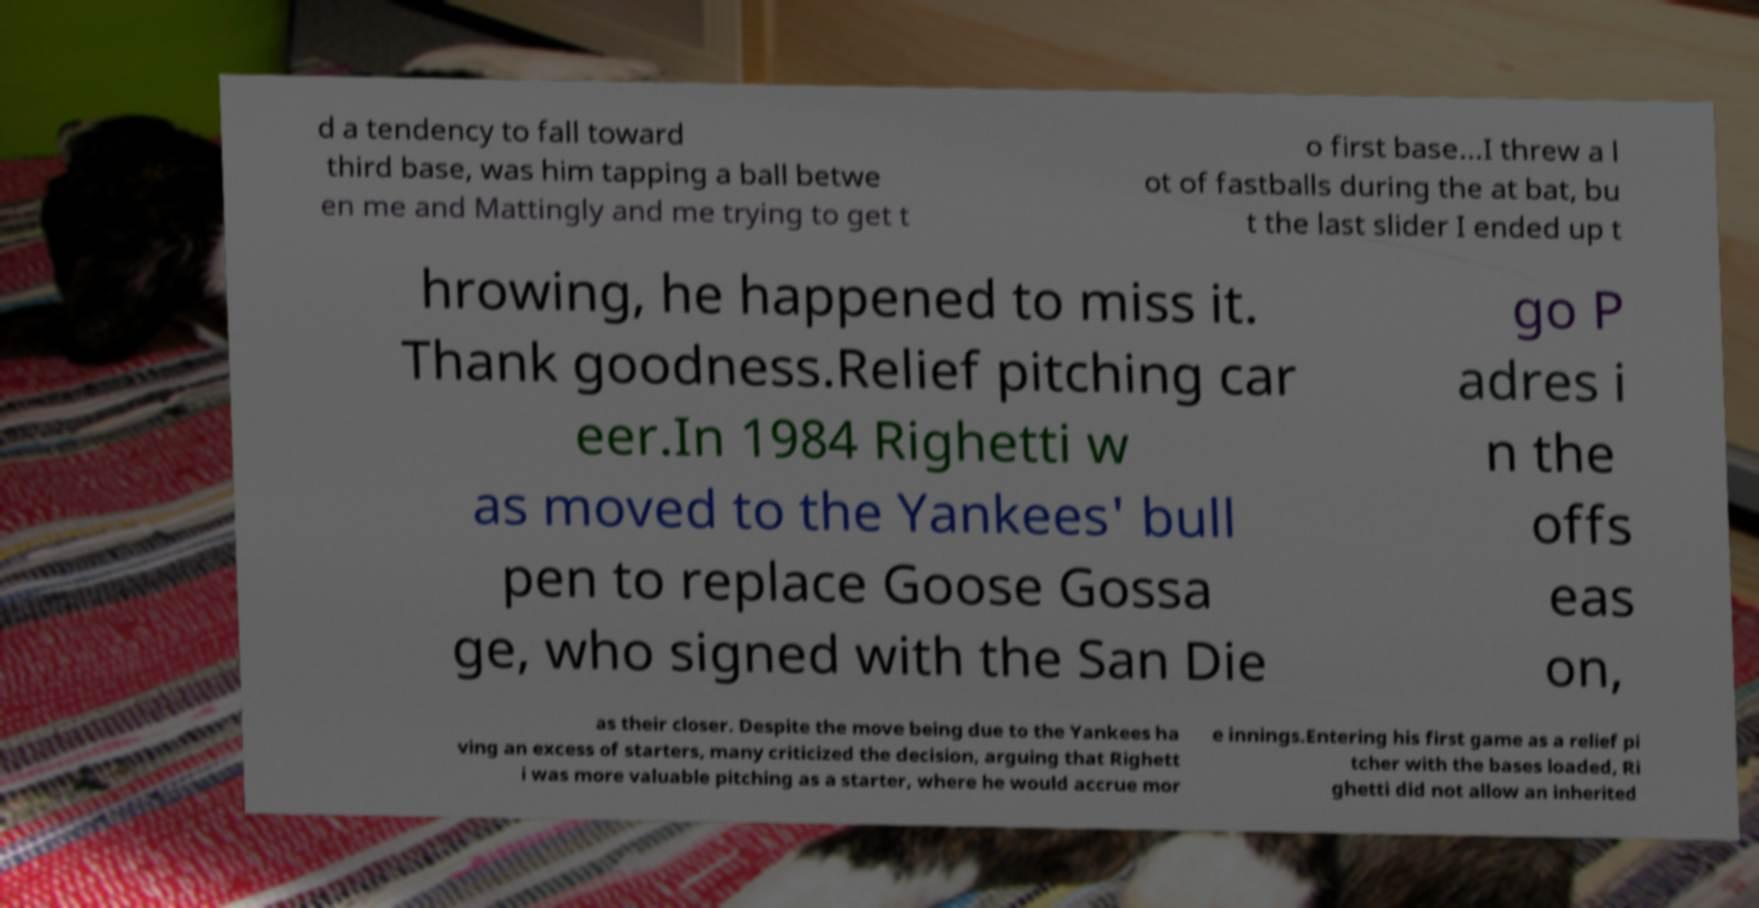Please identify and transcribe the text found in this image. d a tendency to fall toward third base, was him tapping a ball betwe en me and Mattingly and me trying to get t o first base...I threw a l ot of fastballs during the at bat, bu t the last slider I ended up t hrowing, he happened to miss it. Thank goodness.Relief pitching car eer.In 1984 Righetti w as moved to the Yankees' bull pen to replace Goose Gossa ge, who signed with the San Die go P adres i n the offs eas on, as their closer. Despite the move being due to the Yankees ha ving an excess of starters, many criticized the decision, arguing that Righett i was more valuable pitching as a starter, where he would accrue mor e innings.Entering his first game as a relief pi tcher with the bases loaded, Ri ghetti did not allow an inherited 